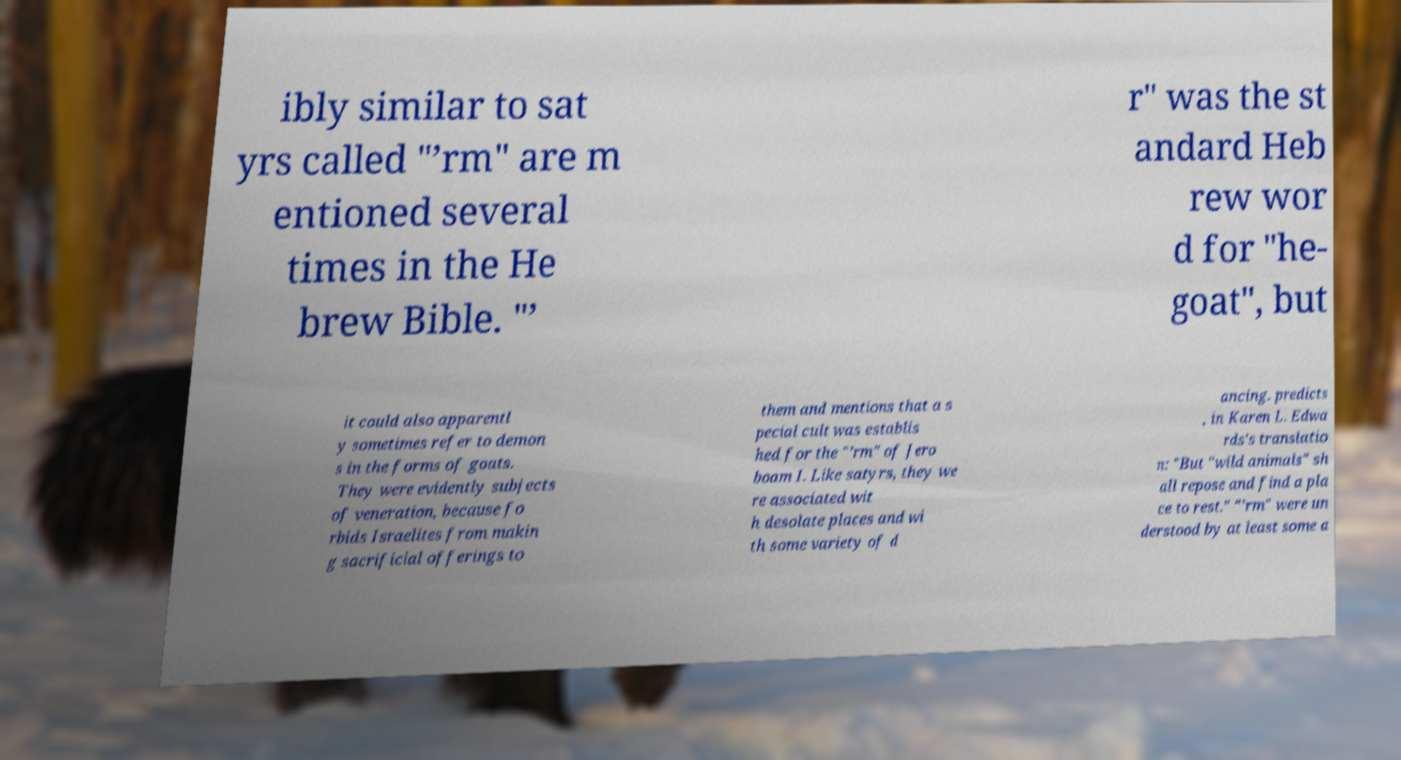Please identify and transcribe the text found in this image. ibly similar to sat yrs called "’rm" are m entioned several times in the He brew Bible. "’ r" was the st andard Heb rew wor d for "he- goat", but it could also apparentl y sometimes refer to demon s in the forms of goats. They were evidently subjects of veneration, because fo rbids Israelites from makin g sacrificial offerings to them and mentions that a s pecial cult was establis hed for the "’rm" of Jero boam I. Like satyrs, they we re associated wit h desolate places and wi th some variety of d ancing. predicts , in Karen L. Edwa rds's translatio n: "But "wild animals" sh all repose and find a pla ce to rest." "’rm" were un derstood by at least some a 